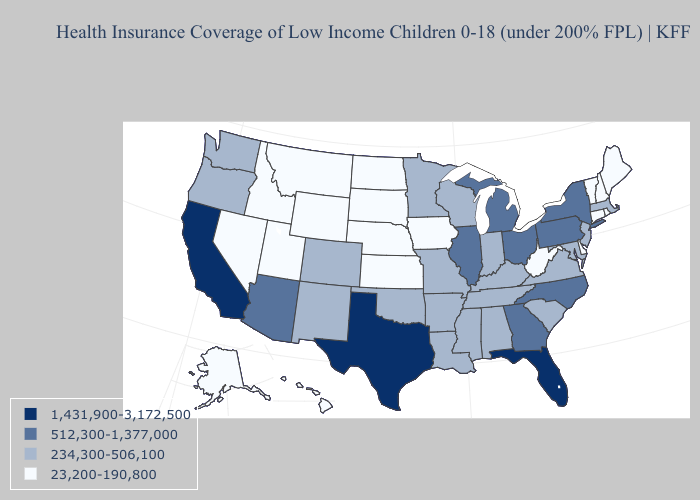Name the states that have a value in the range 23,200-190,800?
Short answer required. Alaska, Connecticut, Delaware, Hawaii, Idaho, Iowa, Kansas, Maine, Montana, Nebraska, Nevada, New Hampshire, North Dakota, Rhode Island, South Dakota, Utah, Vermont, West Virginia, Wyoming. Which states hav the highest value in the Northeast?
Quick response, please. New York, Pennsylvania. Does Maine have the lowest value in the Northeast?
Concise answer only. Yes. Among the states that border Oregon , which have the highest value?
Concise answer only. California. What is the value of Maryland?
Be succinct. 234,300-506,100. Name the states that have a value in the range 1,431,900-3,172,500?
Give a very brief answer. California, Florida, Texas. What is the highest value in the USA?
Answer briefly. 1,431,900-3,172,500. Among the states that border Virginia , which have the highest value?
Keep it brief. North Carolina. What is the highest value in the USA?
Write a very short answer. 1,431,900-3,172,500. What is the value of North Dakota?
Answer briefly. 23,200-190,800. What is the value of Wyoming?
Concise answer only. 23,200-190,800. Does Florida have the highest value in the USA?
Quick response, please. Yes. Name the states that have a value in the range 1,431,900-3,172,500?
Short answer required. California, Florida, Texas. How many symbols are there in the legend?
Concise answer only. 4. Which states hav the highest value in the South?
Concise answer only. Florida, Texas. 